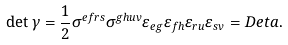Convert formula to latex. <formula><loc_0><loc_0><loc_500><loc_500>\det \gamma = \frac { 1 } { 2 } \sigma ^ { e f r s } \sigma ^ { g h u v } \varepsilon _ { e g } \varepsilon _ { f h } \varepsilon _ { r u } \varepsilon _ { s v } = D e t a .</formula> 